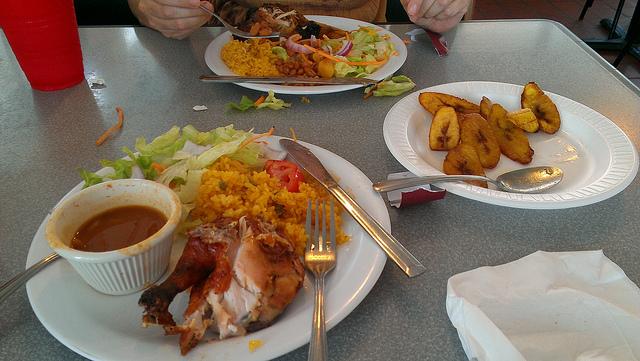What food is on the plate with the spoon?
Write a very short answer. Potatoes. Is there a sandwich with the soup?
Keep it brief. No. How many forks in the picture?
Write a very short answer. 1. Where is the pink cup?
Short answer required. Top left. 